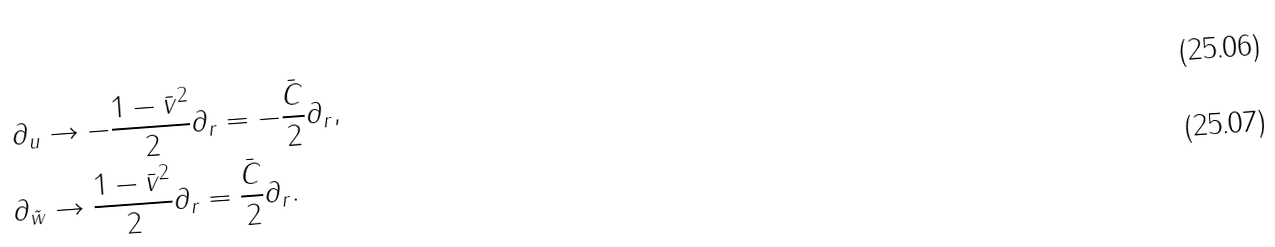<formula> <loc_0><loc_0><loc_500><loc_500>\partial _ { u } & \rightarrow - \frac { 1 - \bar { v } ^ { 2 } } { 2 } \partial _ { r } = - \frac { \bar { C } } { 2 } \partial _ { r } , \\ \partial _ { \tilde { w } } & \rightarrow \frac { 1 - \bar { v } ^ { 2 } } { 2 } \partial _ { r } = \frac { \bar { C } } { 2 } \partial _ { r } .</formula> 